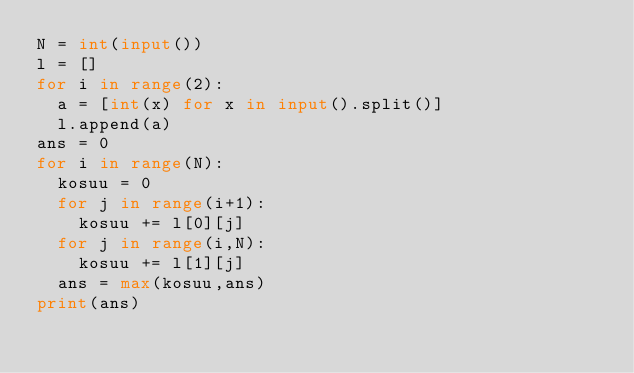Convert code to text. <code><loc_0><loc_0><loc_500><loc_500><_Python_>N = int(input())
l = []
for i in range(2):
  a = [int(x) for x in input().split()]
  l.append(a)
ans = 0
for i in range(N):
  kosuu = 0
  for j in range(i+1):
    kosuu += l[0][j]
  for j in range(i,N):
    kosuu += l[1][j]
  ans = max(kosuu,ans)
print(ans)</code> 